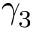<formula> <loc_0><loc_0><loc_500><loc_500>\gamma _ { 3 }</formula> 